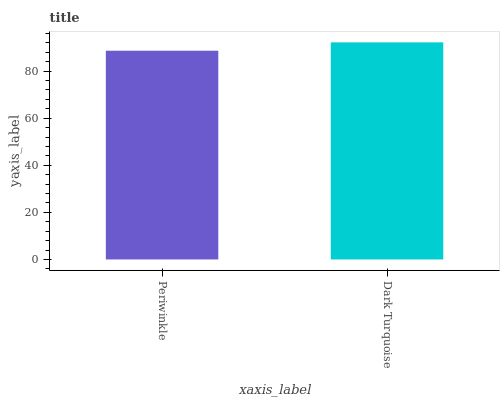Is Periwinkle the minimum?
Answer yes or no. Yes. Is Dark Turquoise the maximum?
Answer yes or no. Yes. Is Dark Turquoise the minimum?
Answer yes or no. No. Is Dark Turquoise greater than Periwinkle?
Answer yes or no. Yes. Is Periwinkle less than Dark Turquoise?
Answer yes or no. Yes. Is Periwinkle greater than Dark Turquoise?
Answer yes or no. No. Is Dark Turquoise less than Periwinkle?
Answer yes or no. No. Is Dark Turquoise the high median?
Answer yes or no. Yes. Is Periwinkle the low median?
Answer yes or no. Yes. Is Periwinkle the high median?
Answer yes or no. No. Is Dark Turquoise the low median?
Answer yes or no. No. 